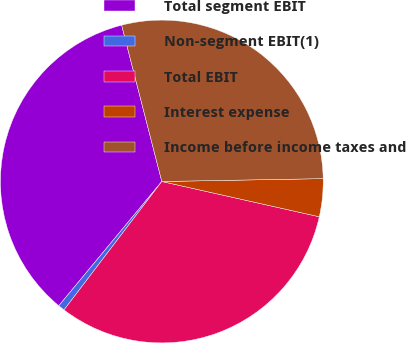Convert chart to OTSL. <chart><loc_0><loc_0><loc_500><loc_500><pie_chart><fcel>Total segment EBIT<fcel>Non-segment EBIT(1)<fcel>Total EBIT<fcel>Interest expense<fcel>Income before income taxes and<nl><fcel>34.98%<fcel>0.66%<fcel>31.85%<fcel>3.79%<fcel>28.72%<nl></chart> 